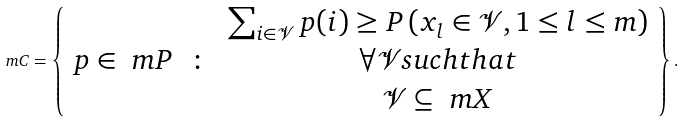<formula> <loc_0><loc_0><loc_500><loc_500>\ m C = \left \{ \begin{array} { c c c } & & \sum _ { i \in \mathcal { V } } p ( i ) \geq P \left ( x _ { l } \in \mathcal { V } , 1 \leq l \leq m \right ) \\ p \in \ m P & \colon & \forall \mathcal { V } s u c h t h a t \\ & & \mathcal { V } \subseteq \ m X \end{array} \right \} .</formula> 